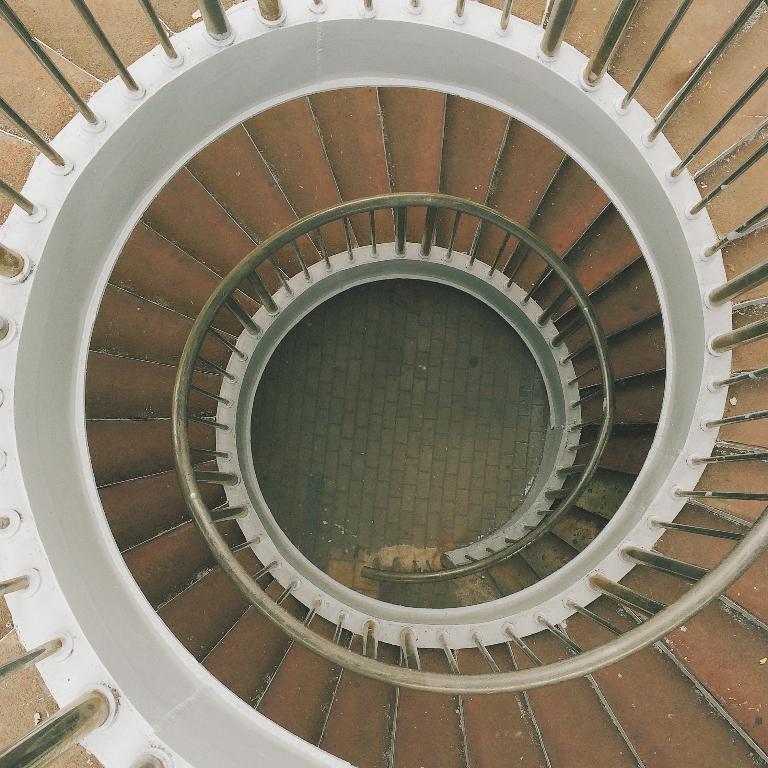Please provide a concise description of this image. In this image we can see stairs and there are railings. 